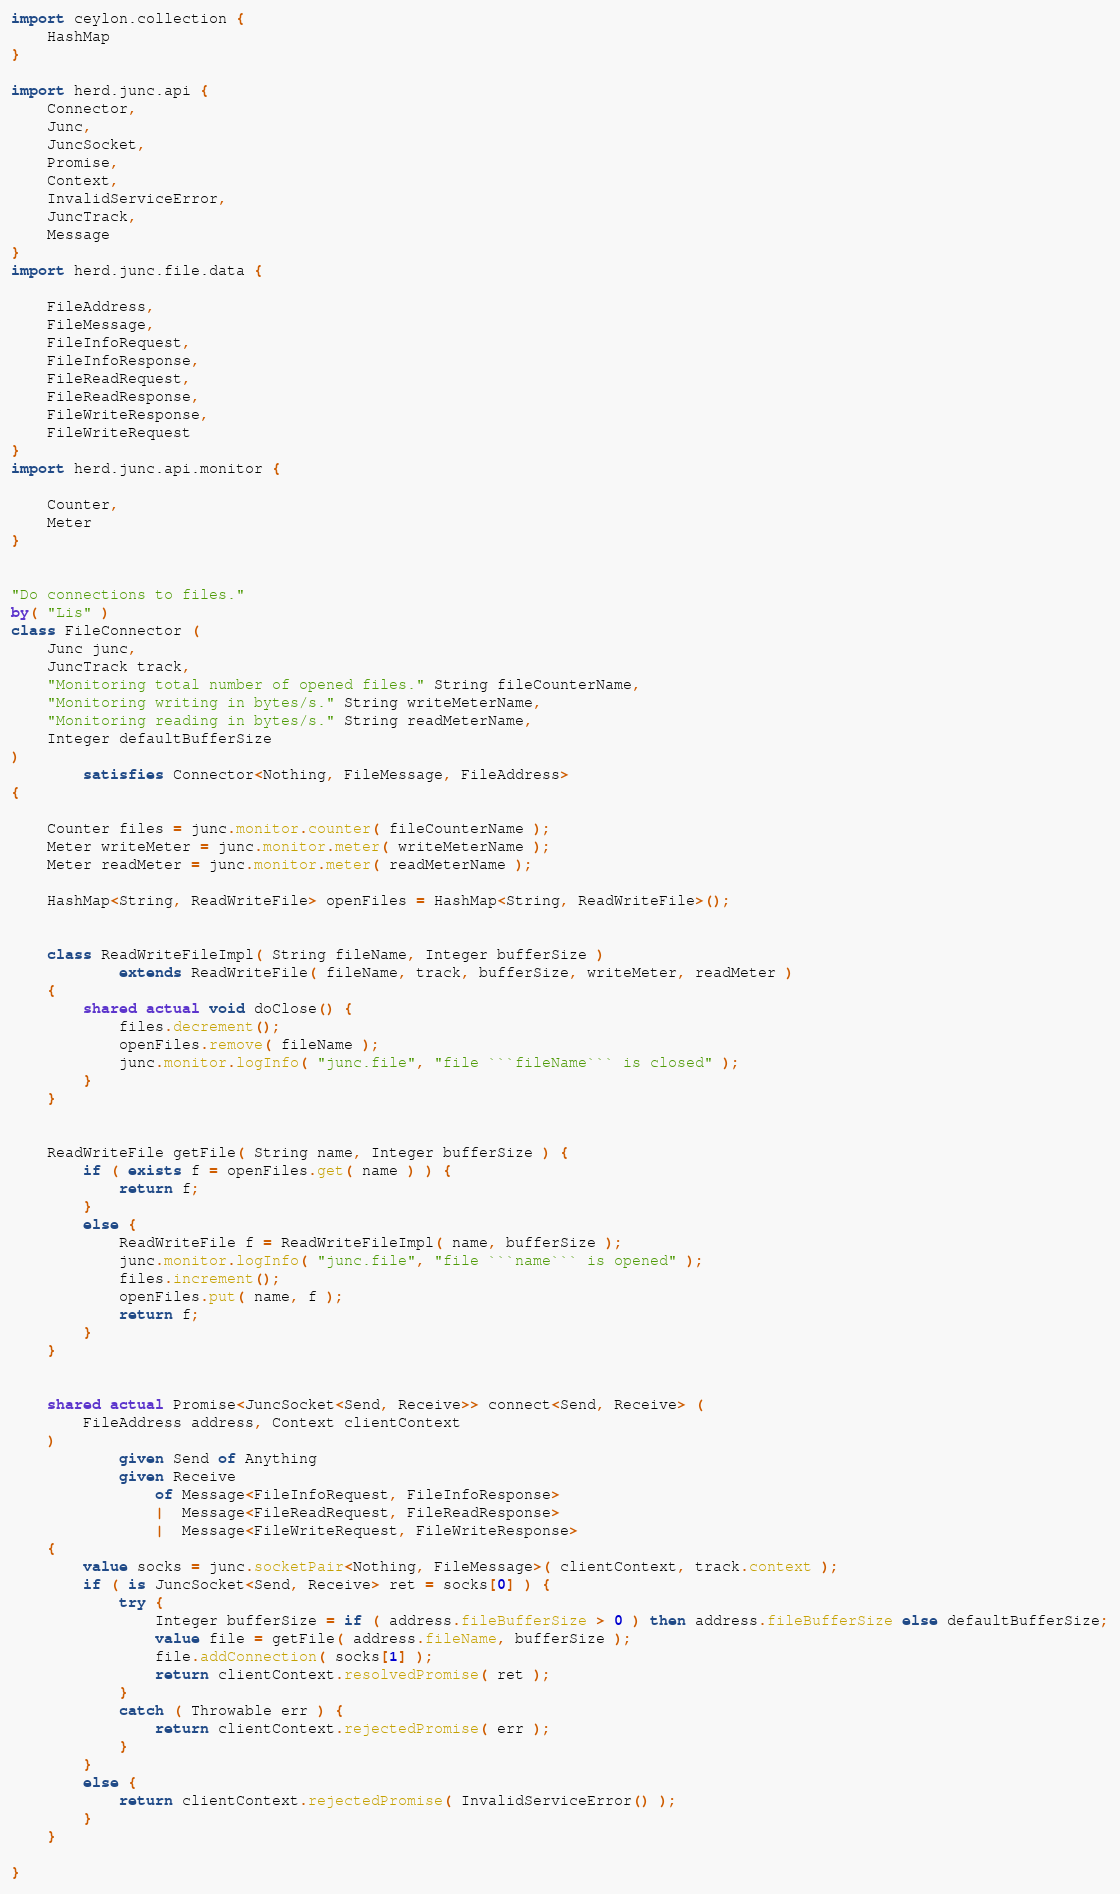Convert code to text. <code><loc_0><loc_0><loc_500><loc_500><_Ceylon_>import ceylon.collection {
	HashMap
}

import herd.junc.api {
	Connector,
	Junc,
	JuncSocket,
	Promise,
	Context,
	InvalidServiceError,
	JuncTrack,
	Message
}
import herd.junc.file.data {

	FileAddress,
	FileMessage,
	FileInfoRequest,
	FileInfoResponse,
	FileReadRequest,
	FileReadResponse,
	FileWriteResponse,
	FileWriteRequest
}
import herd.junc.api.monitor {

	Counter,
	Meter
}


"Do connections to files."
by( "Lis" )
class FileConnector (
	Junc junc,
	JuncTrack track,
	"Monitoring total number of opened files." String fileCounterName,
	"Monitoring writing in bytes/s." String writeMeterName,
	"Monitoring reading in bytes/s." String readMeterName,
	Integer defaultBufferSize
)
		satisfies Connector<Nothing, FileMessage, FileAddress>
{
	
	Counter files = junc.monitor.counter( fileCounterName );
	Meter writeMeter = junc.monitor.meter( writeMeterName );
	Meter readMeter = junc.monitor.meter( readMeterName );
	
	HashMap<String, ReadWriteFile> openFiles = HashMap<String, ReadWriteFile>();
	
	
	class ReadWriteFileImpl( String fileName, Integer bufferSize )
			extends ReadWriteFile( fileName, track, bufferSize, writeMeter, readMeter )
	{
		shared actual void doClose() {
			files.decrement();
			openFiles.remove( fileName );
			junc.monitor.logInfo( "junc.file", "file ```fileName``` is closed" );
		}
	}
	
	
	ReadWriteFile getFile( String name, Integer bufferSize ) {
		if ( exists f = openFiles.get( name ) ) {
			return f;
		}
		else {
			ReadWriteFile f = ReadWriteFileImpl( name, bufferSize );
			junc.monitor.logInfo( "junc.file", "file ```name``` is opened" );
			files.increment();
			openFiles.put( name, f );
			return f;
		}
	}
	
	
	shared actual Promise<JuncSocket<Send, Receive>> connect<Send, Receive> (
		FileAddress address, Context clientContext
	)
			given Send of Anything
			given Receive
				of Message<FileInfoRequest, FileInfoResponse>
				|  Message<FileReadRequest, FileReadResponse>
				|  Message<FileWriteRequest, FileWriteResponse>
	{
		value socks = junc.socketPair<Nothing, FileMessage>( clientContext, track.context );
		if ( is JuncSocket<Send, Receive> ret = socks[0] ) {
			try {
				Integer bufferSize = if ( address.fileBufferSize > 0 ) then address.fileBufferSize else defaultBufferSize;
				value file = getFile( address.fileName, bufferSize );
				file.addConnection( socks[1] );
				return clientContext.resolvedPromise( ret );
			}
			catch ( Throwable err ) {
				return clientContext.rejectedPromise( err );
			}
		}
		else {
			return clientContext.rejectedPromise( InvalidServiceError() );
		}
	}
	
}
</code> 